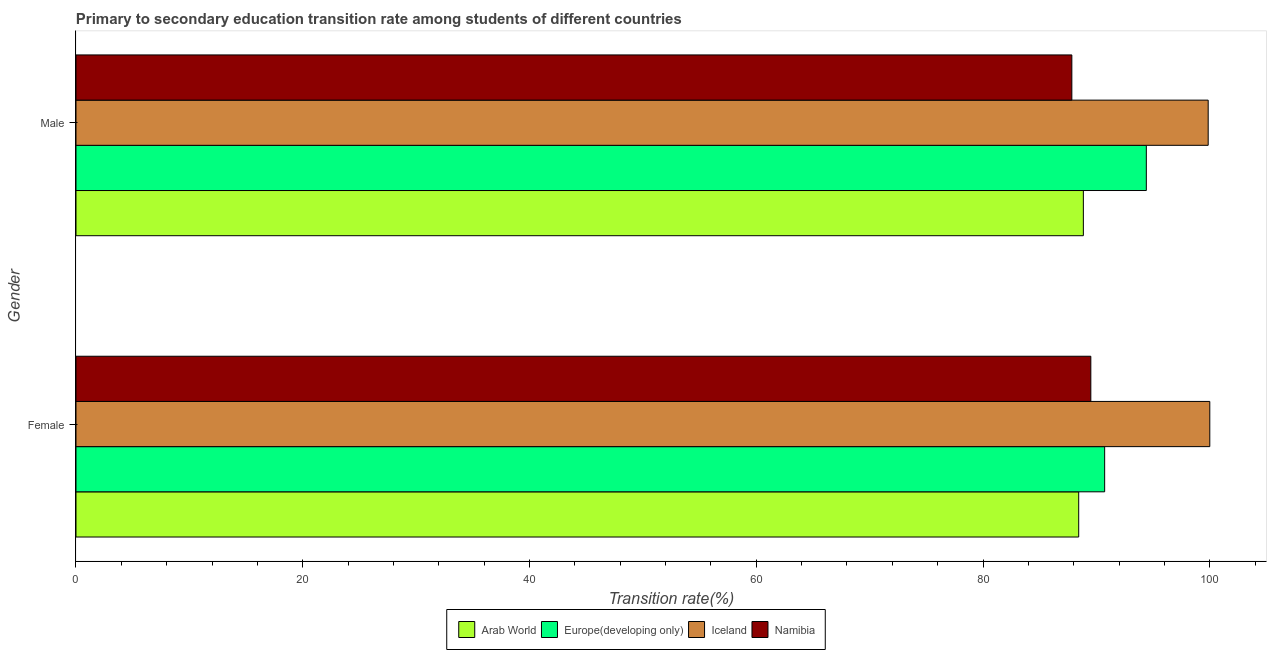How many different coloured bars are there?
Make the answer very short. 4. How many groups of bars are there?
Your answer should be very brief. 2. Are the number of bars on each tick of the Y-axis equal?
Your response must be concise. Yes. How many bars are there on the 1st tick from the bottom?
Make the answer very short. 4. What is the transition rate among female students in Iceland?
Keep it short and to the point. 100. Across all countries, what is the minimum transition rate among male students?
Give a very brief answer. 87.83. In which country was the transition rate among female students maximum?
Ensure brevity in your answer.  Iceland. In which country was the transition rate among male students minimum?
Your response must be concise. Namibia. What is the total transition rate among male students in the graph?
Give a very brief answer. 370.94. What is the difference between the transition rate among female students in Namibia and that in Europe(developing only)?
Make the answer very short. -1.22. What is the difference between the transition rate among female students in Iceland and the transition rate among male students in Arab World?
Provide a succinct answer. 11.15. What is the average transition rate among female students per country?
Provide a short and direct response. 92.17. What is the difference between the transition rate among female students and transition rate among male students in Iceland?
Keep it short and to the point. 0.14. In how many countries, is the transition rate among male students greater than 100 %?
Give a very brief answer. 0. What is the ratio of the transition rate among female students in Arab World to that in Namibia?
Your answer should be compact. 0.99. What does the 2nd bar from the top in Male represents?
Ensure brevity in your answer.  Iceland. What does the 4th bar from the bottom in Female represents?
Offer a very short reply. Namibia. How many bars are there?
Make the answer very short. 8. Does the graph contain any zero values?
Provide a short and direct response. No. Does the graph contain grids?
Your answer should be compact. No. Where does the legend appear in the graph?
Your response must be concise. Bottom center. How many legend labels are there?
Your answer should be compact. 4. What is the title of the graph?
Offer a very short reply. Primary to secondary education transition rate among students of different countries. What is the label or title of the X-axis?
Offer a terse response. Transition rate(%). What is the Transition rate(%) in Arab World in Female?
Provide a short and direct response. 88.44. What is the Transition rate(%) in Europe(developing only) in Female?
Your response must be concise. 90.73. What is the Transition rate(%) of Namibia in Female?
Offer a very short reply. 89.51. What is the Transition rate(%) of Arab World in Male?
Ensure brevity in your answer.  88.85. What is the Transition rate(%) in Europe(developing only) in Male?
Provide a succinct answer. 94.4. What is the Transition rate(%) in Iceland in Male?
Ensure brevity in your answer.  99.86. What is the Transition rate(%) in Namibia in Male?
Ensure brevity in your answer.  87.83. Across all Gender, what is the maximum Transition rate(%) in Arab World?
Ensure brevity in your answer.  88.85. Across all Gender, what is the maximum Transition rate(%) in Europe(developing only)?
Offer a terse response. 94.4. Across all Gender, what is the maximum Transition rate(%) in Namibia?
Offer a terse response. 89.51. Across all Gender, what is the minimum Transition rate(%) in Arab World?
Your answer should be compact. 88.44. Across all Gender, what is the minimum Transition rate(%) of Europe(developing only)?
Keep it short and to the point. 90.73. Across all Gender, what is the minimum Transition rate(%) in Iceland?
Offer a terse response. 99.86. Across all Gender, what is the minimum Transition rate(%) of Namibia?
Provide a short and direct response. 87.83. What is the total Transition rate(%) in Arab World in the graph?
Give a very brief answer. 177.29. What is the total Transition rate(%) in Europe(developing only) in the graph?
Your response must be concise. 185.13. What is the total Transition rate(%) of Iceland in the graph?
Your response must be concise. 199.86. What is the total Transition rate(%) of Namibia in the graph?
Offer a very short reply. 177.34. What is the difference between the Transition rate(%) of Arab World in Female and that in Male?
Keep it short and to the point. -0.41. What is the difference between the Transition rate(%) in Europe(developing only) in Female and that in Male?
Give a very brief answer. -3.67. What is the difference between the Transition rate(%) of Iceland in Female and that in Male?
Your answer should be compact. 0.14. What is the difference between the Transition rate(%) in Namibia in Female and that in Male?
Offer a very short reply. 1.68. What is the difference between the Transition rate(%) in Arab World in Female and the Transition rate(%) in Europe(developing only) in Male?
Give a very brief answer. -5.96. What is the difference between the Transition rate(%) of Arab World in Female and the Transition rate(%) of Iceland in Male?
Provide a succinct answer. -11.42. What is the difference between the Transition rate(%) in Arab World in Female and the Transition rate(%) in Namibia in Male?
Your response must be concise. 0.6. What is the difference between the Transition rate(%) of Europe(developing only) in Female and the Transition rate(%) of Iceland in Male?
Offer a terse response. -9.13. What is the difference between the Transition rate(%) of Europe(developing only) in Female and the Transition rate(%) of Namibia in Male?
Provide a short and direct response. 2.89. What is the difference between the Transition rate(%) in Iceland in Female and the Transition rate(%) in Namibia in Male?
Keep it short and to the point. 12.17. What is the average Transition rate(%) of Arab World per Gender?
Offer a terse response. 88.64. What is the average Transition rate(%) of Europe(developing only) per Gender?
Offer a terse response. 92.56. What is the average Transition rate(%) of Iceland per Gender?
Your answer should be very brief. 99.93. What is the average Transition rate(%) in Namibia per Gender?
Offer a terse response. 88.67. What is the difference between the Transition rate(%) of Arab World and Transition rate(%) of Europe(developing only) in Female?
Your response must be concise. -2.29. What is the difference between the Transition rate(%) of Arab World and Transition rate(%) of Iceland in Female?
Make the answer very short. -11.56. What is the difference between the Transition rate(%) in Arab World and Transition rate(%) in Namibia in Female?
Offer a terse response. -1.07. What is the difference between the Transition rate(%) in Europe(developing only) and Transition rate(%) in Iceland in Female?
Keep it short and to the point. -9.27. What is the difference between the Transition rate(%) in Europe(developing only) and Transition rate(%) in Namibia in Female?
Keep it short and to the point. 1.22. What is the difference between the Transition rate(%) of Iceland and Transition rate(%) of Namibia in Female?
Ensure brevity in your answer.  10.49. What is the difference between the Transition rate(%) in Arab World and Transition rate(%) in Europe(developing only) in Male?
Provide a succinct answer. -5.55. What is the difference between the Transition rate(%) of Arab World and Transition rate(%) of Iceland in Male?
Your response must be concise. -11.01. What is the difference between the Transition rate(%) of Arab World and Transition rate(%) of Namibia in Male?
Provide a succinct answer. 1.02. What is the difference between the Transition rate(%) of Europe(developing only) and Transition rate(%) of Iceland in Male?
Ensure brevity in your answer.  -5.46. What is the difference between the Transition rate(%) of Europe(developing only) and Transition rate(%) of Namibia in Male?
Make the answer very short. 6.57. What is the difference between the Transition rate(%) in Iceland and Transition rate(%) in Namibia in Male?
Provide a succinct answer. 12.03. What is the ratio of the Transition rate(%) of Arab World in Female to that in Male?
Your response must be concise. 1. What is the ratio of the Transition rate(%) in Europe(developing only) in Female to that in Male?
Give a very brief answer. 0.96. What is the ratio of the Transition rate(%) of Namibia in Female to that in Male?
Keep it short and to the point. 1.02. What is the difference between the highest and the second highest Transition rate(%) of Arab World?
Offer a terse response. 0.41. What is the difference between the highest and the second highest Transition rate(%) in Europe(developing only)?
Your answer should be very brief. 3.67. What is the difference between the highest and the second highest Transition rate(%) of Iceland?
Your response must be concise. 0.14. What is the difference between the highest and the second highest Transition rate(%) of Namibia?
Your answer should be very brief. 1.68. What is the difference between the highest and the lowest Transition rate(%) in Arab World?
Give a very brief answer. 0.41. What is the difference between the highest and the lowest Transition rate(%) in Europe(developing only)?
Make the answer very short. 3.67. What is the difference between the highest and the lowest Transition rate(%) of Iceland?
Your response must be concise. 0.14. What is the difference between the highest and the lowest Transition rate(%) of Namibia?
Your answer should be compact. 1.68. 